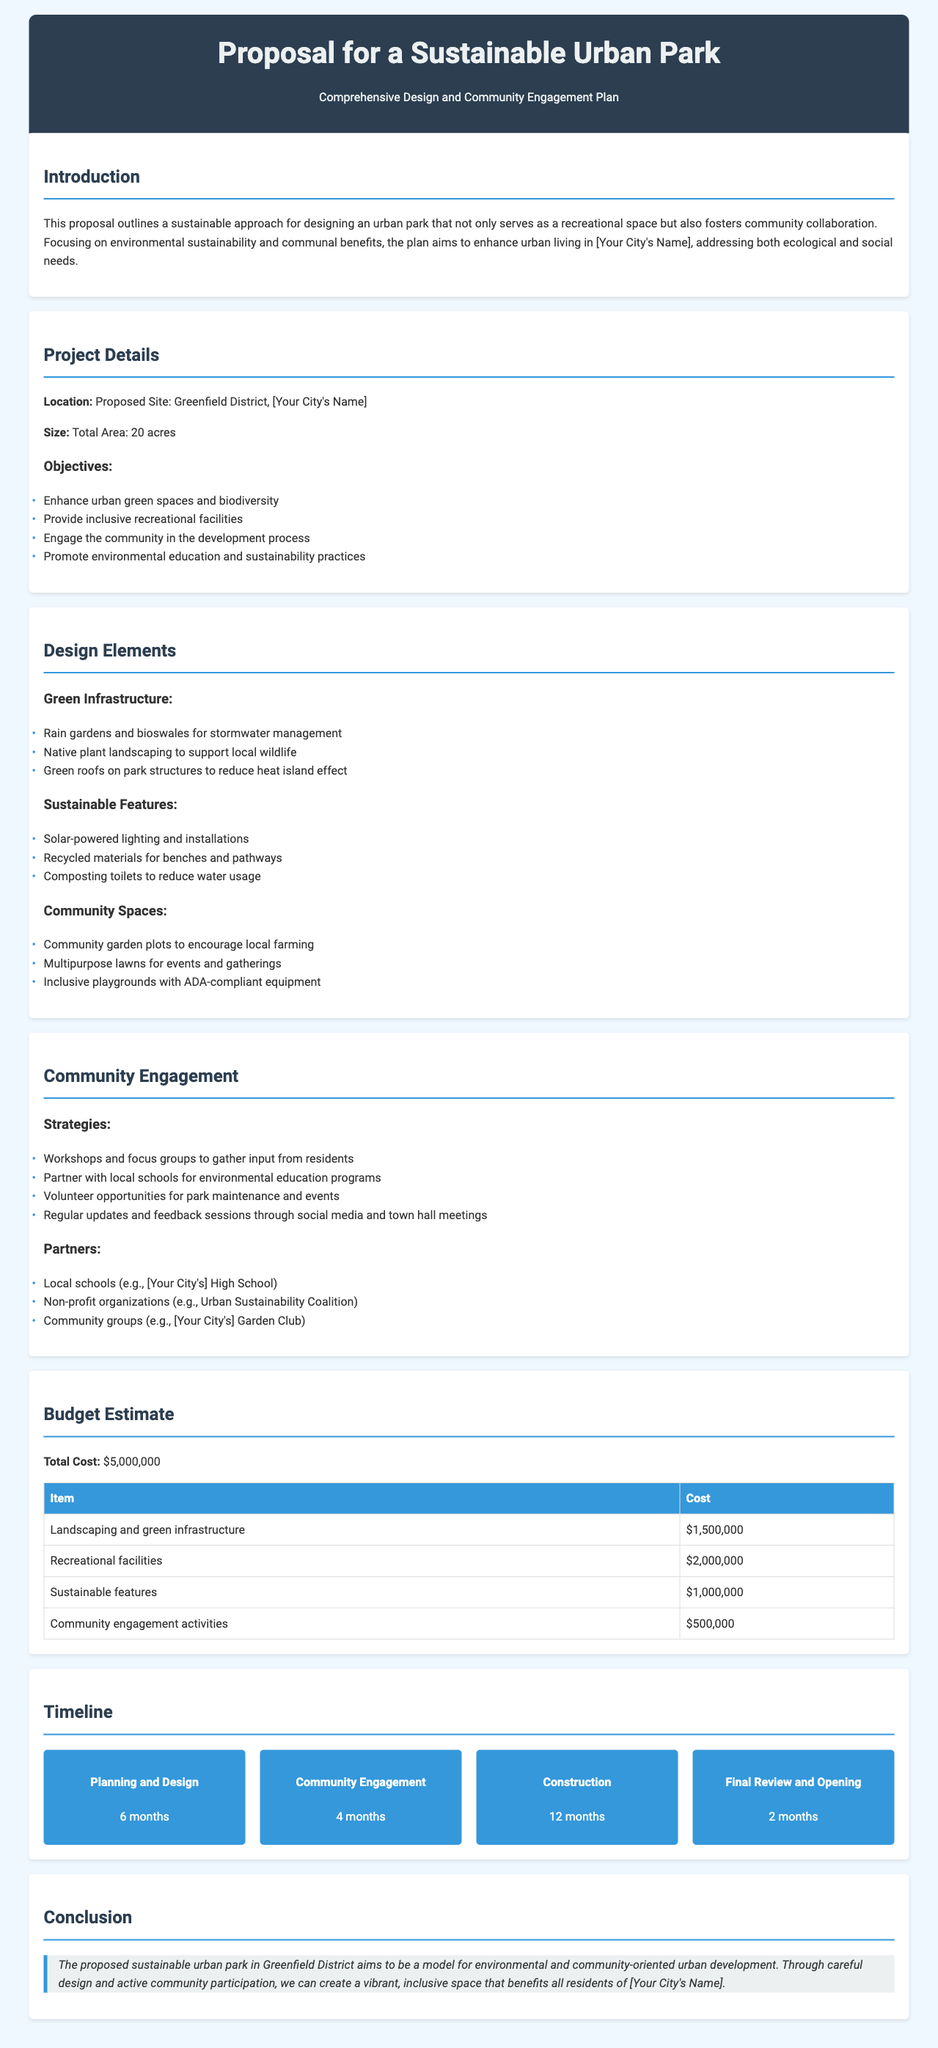What is the location of the proposed park? The location is specified in the document as the Greenfield District in [Your City's Name].
Answer: Greenfield District, [Your City's Name] What is the total area of the proposed urban park? The total area is mentioned clearly in the document under project details.
Answer: 20 acres What is the total cost of the project? The total cost is provided in the budget estimate section of the document.
Answer: $5,000,000 How long is the construction phase planned to last? The timeline section outlines the duration for the construction phase.
Answer: 12 months What community engagement strategy involves working with local schools? The document highlights several strategies aimed at community engagement.
Answer: Partner with local schools for environmental education programs What is the budget for landscaping and green infrastructure? Details regarding the budget allocation for specific items can be found in the budget estimate section.
Answer: $1,500,000 Which feature helps to manage stormwater? The document lists specific elements categorized under green infrastructure related to stormwater management.
Answer: Rain gardens and bioswales How many months is dedicated to community engagement in the timeline? The timeline section specifies the duration allocated to community engagement.
Answer: 4 months What is the main goal of the proposed urban park? The introduction section outlines the overarching goals of the urban park.
Answer: Enhance urban green spaces and biodiversity 